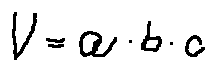<formula> <loc_0><loc_0><loc_500><loc_500>V = a \cdot b \cdot c</formula> 